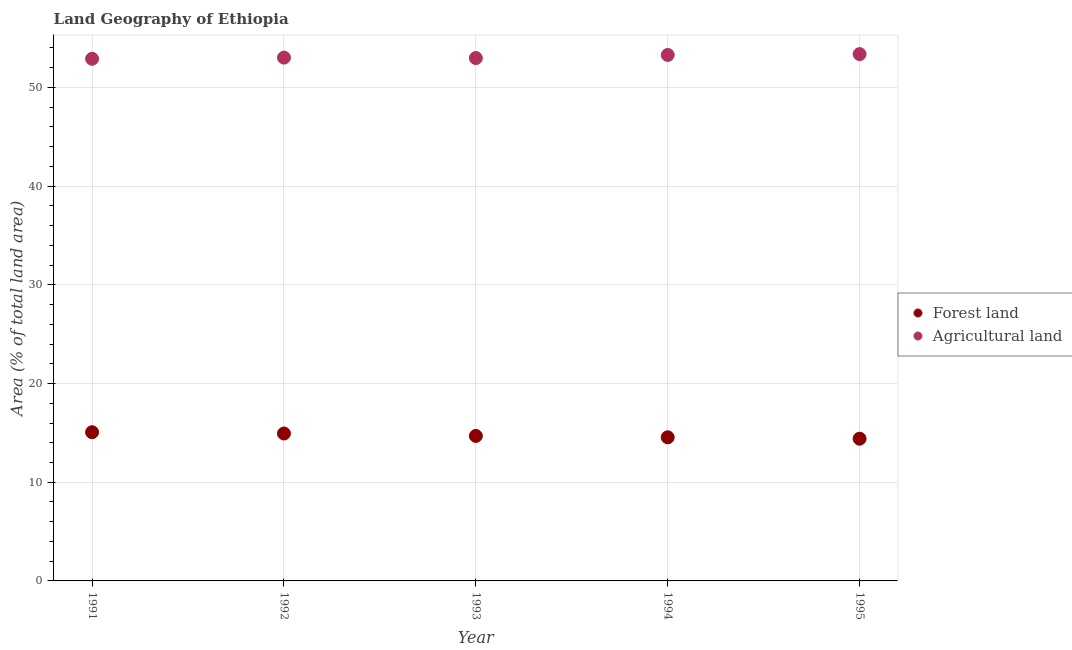What is the percentage of land area under agriculture in 1994?
Ensure brevity in your answer.  53.29. Across all years, what is the maximum percentage of land area under forests?
Offer a very short reply. 15.07. Across all years, what is the minimum percentage of land area under forests?
Your answer should be very brief. 14.41. In which year was the percentage of land area under forests minimum?
Offer a terse response. 1995. What is the total percentage of land area under agriculture in the graph?
Ensure brevity in your answer.  265.58. What is the difference between the percentage of land area under forests in 1992 and that in 1994?
Offer a very short reply. 0.39. What is the difference between the percentage of land area under agriculture in 1993 and the percentage of land area under forests in 1995?
Your response must be concise. 38.57. What is the average percentage of land area under forests per year?
Provide a short and direct response. 14.73. In the year 1993, what is the difference between the percentage of land area under forests and percentage of land area under agriculture?
Offer a very short reply. -38.29. What is the ratio of the percentage of land area under forests in 1994 to that in 1995?
Make the answer very short. 1.01. What is the difference between the highest and the second highest percentage of land area under forests?
Your answer should be compact. 0.13. What is the difference between the highest and the lowest percentage of land area under forests?
Keep it short and to the point. 0.66. In how many years, is the percentage of land area under forests greater than the average percentage of land area under forests taken over all years?
Offer a terse response. 2. Is the sum of the percentage of land area under agriculture in 1991 and 1994 greater than the maximum percentage of land area under forests across all years?
Provide a short and direct response. Yes. How many dotlines are there?
Give a very brief answer. 2. What is the difference between two consecutive major ticks on the Y-axis?
Your answer should be very brief. 10. Does the graph contain any zero values?
Offer a very short reply. No. Does the graph contain grids?
Your answer should be compact. Yes. Where does the legend appear in the graph?
Offer a very short reply. Center right. How many legend labels are there?
Make the answer very short. 2. What is the title of the graph?
Give a very brief answer. Land Geography of Ethiopia. What is the label or title of the Y-axis?
Provide a succinct answer. Area (% of total land area). What is the Area (% of total land area) in Forest land in 1991?
Make the answer very short. 15.07. What is the Area (% of total land area) in Agricultural land in 1991?
Your answer should be very brief. 52.91. What is the Area (% of total land area) in Forest land in 1992?
Provide a succinct answer. 14.94. What is the Area (% of total land area) in Agricultural land in 1992?
Make the answer very short. 53.02. What is the Area (% of total land area) of Forest land in 1993?
Your response must be concise. 14.69. What is the Area (% of total land area) in Agricultural land in 1993?
Provide a succinct answer. 52.98. What is the Area (% of total land area) in Forest land in 1994?
Your answer should be very brief. 14.55. What is the Area (% of total land area) in Agricultural land in 1994?
Offer a terse response. 53.29. What is the Area (% of total land area) in Forest land in 1995?
Provide a succinct answer. 14.41. What is the Area (% of total land area) of Agricultural land in 1995?
Give a very brief answer. 53.38. Across all years, what is the maximum Area (% of total land area) of Forest land?
Make the answer very short. 15.07. Across all years, what is the maximum Area (% of total land area) in Agricultural land?
Provide a short and direct response. 53.38. Across all years, what is the minimum Area (% of total land area) of Forest land?
Make the answer very short. 14.41. Across all years, what is the minimum Area (% of total land area) in Agricultural land?
Your answer should be very brief. 52.91. What is the total Area (% of total land area) in Forest land in the graph?
Provide a short and direct response. 73.65. What is the total Area (% of total land area) of Agricultural land in the graph?
Keep it short and to the point. 265.58. What is the difference between the Area (% of total land area) in Forest land in 1991 and that in 1992?
Ensure brevity in your answer.  0.13. What is the difference between the Area (% of total land area) of Agricultural land in 1991 and that in 1992?
Your answer should be compact. -0.12. What is the difference between the Area (% of total land area) of Forest land in 1991 and that in 1993?
Your answer should be compact. 0.38. What is the difference between the Area (% of total land area) of Agricultural land in 1991 and that in 1993?
Offer a terse response. -0.07. What is the difference between the Area (% of total land area) of Forest land in 1991 and that in 1994?
Make the answer very short. 0.52. What is the difference between the Area (% of total land area) in Agricultural land in 1991 and that in 1994?
Provide a succinct answer. -0.39. What is the difference between the Area (% of total land area) in Forest land in 1991 and that in 1995?
Give a very brief answer. 0.66. What is the difference between the Area (% of total land area) of Agricultural land in 1991 and that in 1995?
Provide a succinct answer. -0.47. What is the difference between the Area (% of total land area) of Forest land in 1992 and that in 1993?
Offer a very short reply. 0.24. What is the difference between the Area (% of total land area) in Agricultural land in 1992 and that in 1993?
Give a very brief answer. 0.05. What is the difference between the Area (% of total land area) in Forest land in 1992 and that in 1994?
Provide a succinct answer. 0.39. What is the difference between the Area (% of total land area) in Agricultural land in 1992 and that in 1994?
Offer a terse response. -0.27. What is the difference between the Area (% of total land area) of Forest land in 1992 and that in 1995?
Provide a succinct answer. 0.53. What is the difference between the Area (% of total land area) of Agricultural land in 1992 and that in 1995?
Your answer should be compact. -0.35. What is the difference between the Area (% of total land area) of Forest land in 1993 and that in 1994?
Provide a short and direct response. 0.14. What is the difference between the Area (% of total land area) in Agricultural land in 1993 and that in 1994?
Offer a terse response. -0.31. What is the difference between the Area (% of total land area) of Forest land in 1993 and that in 1995?
Make the answer very short. 0.28. What is the difference between the Area (% of total land area) of Agricultural land in 1993 and that in 1995?
Provide a short and direct response. -0.4. What is the difference between the Area (% of total land area) of Forest land in 1994 and that in 1995?
Your answer should be compact. 0.14. What is the difference between the Area (% of total land area) in Agricultural land in 1994 and that in 1995?
Give a very brief answer. -0.09. What is the difference between the Area (% of total land area) in Forest land in 1991 and the Area (% of total land area) in Agricultural land in 1992?
Give a very brief answer. -37.96. What is the difference between the Area (% of total land area) in Forest land in 1991 and the Area (% of total land area) in Agricultural land in 1993?
Make the answer very short. -37.91. What is the difference between the Area (% of total land area) in Forest land in 1991 and the Area (% of total land area) in Agricultural land in 1994?
Provide a short and direct response. -38.22. What is the difference between the Area (% of total land area) in Forest land in 1991 and the Area (% of total land area) in Agricultural land in 1995?
Your response must be concise. -38.31. What is the difference between the Area (% of total land area) in Forest land in 1992 and the Area (% of total land area) in Agricultural land in 1993?
Your answer should be compact. -38.04. What is the difference between the Area (% of total land area) of Forest land in 1992 and the Area (% of total land area) of Agricultural land in 1994?
Your response must be concise. -38.36. What is the difference between the Area (% of total land area) in Forest land in 1992 and the Area (% of total land area) in Agricultural land in 1995?
Your response must be concise. -38.44. What is the difference between the Area (% of total land area) in Forest land in 1993 and the Area (% of total land area) in Agricultural land in 1994?
Provide a succinct answer. -38.6. What is the difference between the Area (% of total land area) in Forest land in 1993 and the Area (% of total land area) in Agricultural land in 1995?
Provide a short and direct response. -38.69. What is the difference between the Area (% of total land area) of Forest land in 1994 and the Area (% of total land area) of Agricultural land in 1995?
Your answer should be compact. -38.83. What is the average Area (% of total land area) of Forest land per year?
Keep it short and to the point. 14.73. What is the average Area (% of total land area) of Agricultural land per year?
Provide a short and direct response. 53.12. In the year 1991, what is the difference between the Area (% of total land area) of Forest land and Area (% of total land area) of Agricultural land?
Make the answer very short. -37.84. In the year 1992, what is the difference between the Area (% of total land area) in Forest land and Area (% of total land area) in Agricultural land?
Your response must be concise. -38.09. In the year 1993, what is the difference between the Area (% of total land area) in Forest land and Area (% of total land area) in Agricultural land?
Give a very brief answer. -38.29. In the year 1994, what is the difference between the Area (% of total land area) of Forest land and Area (% of total land area) of Agricultural land?
Your answer should be compact. -38.74. In the year 1995, what is the difference between the Area (% of total land area) in Forest land and Area (% of total land area) in Agricultural land?
Your response must be concise. -38.97. What is the ratio of the Area (% of total land area) in Forest land in 1991 to that in 1992?
Keep it short and to the point. 1.01. What is the ratio of the Area (% of total land area) of Agricultural land in 1991 to that in 1992?
Ensure brevity in your answer.  1. What is the ratio of the Area (% of total land area) in Forest land in 1991 to that in 1993?
Offer a very short reply. 1.03. What is the ratio of the Area (% of total land area) in Agricultural land in 1991 to that in 1993?
Offer a very short reply. 1. What is the ratio of the Area (% of total land area) in Forest land in 1991 to that in 1994?
Keep it short and to the point. 1.04. What is the ratio of the Area (% of total land area) of Forest land in 1991 to that in 1995?
Give a very brief answer. 1.05. What is the ratio of the Area (% of total land area) of Forest land in 1992 to that in 1993?
Provide a succinct answer. 1.02. What is the ratio of the Area (% of total land area) of Agricultural land in 1992 to that in 1993?
Provide a short and direct response. 1. What is the ratio of the Area (% of total land area) in Forest land in 1992 to that in 1994?
Ensure brevity in your answer.  1.03. What is the ratio of the Area (% of total land area) of Forest land in 1992 to that in 1995?
Keep it short and to the point. 1.04. What is the ratio of the Area (% of total land area) in Agricultural land in 1992 to that in 1995?
Make the answer very short. 0.99. What is the ratio of the Area (% of total land area) of Forest land in 1993 to that in 1994?
Give a very brief answer. 1.01. What is the ratio of the Area (% of total land area) of Agricultural land in 1993 to that in 1994?
Give a very brief answer. 0.99. What is the ratio of the Area (% of total land area) of Forest land in 1993 to that in 1995?
Your response must be concise. 1.02. What is the ratio of the Area (% of total land area) of Forest land in 1994 to that in 1995?
Give a very brief answer. 1.01. What is the ratio of the Area (% of total land area) in Agricultural land in 1994 to that in 1995?
Give a very brief answer. 1. What is the difference between the highest and the second highest Area (% of total land area) in Forest land?
Your answer should be compact. 0.13. What is the difference between the highest and the second highest Area (% of total land area) in Agricultural land?
Your response must be concise. 0.09. What is the difference between the highest and the lowest Area (% of total land area) of Forest land?
Your response must be concise. 0.66. What is the difference between the highest and the lowest Area (% of total land area) of Agricultural land?
Offer a very short reply. 0.47. 